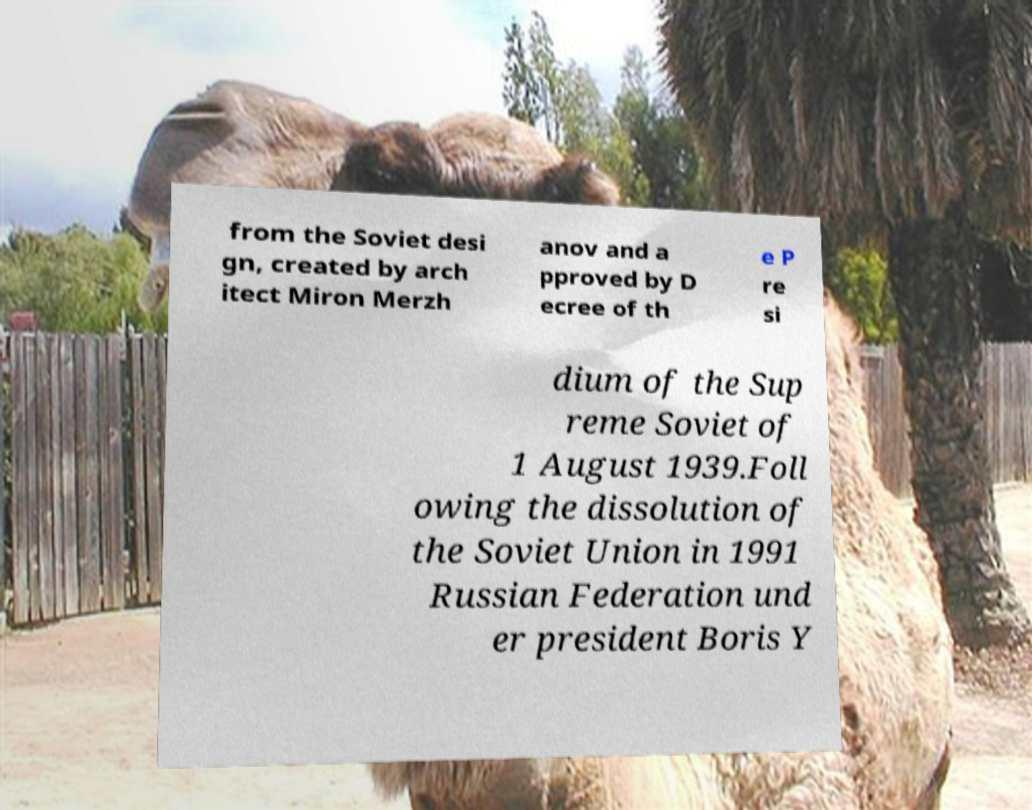Can you read and provide the text displayed in the image?This photo seems to have some interesting text. Can you extract and type it out for me? from the Soviet desi gn, created by arch itect Miron Merzh anov and a pproved by D ecree of th e P re si dium of the Sup reme Soviet of 1 August 1939.Foll owing the dissolution of the Soviet Union in 1991 Russian Federation und er president Boris Y 